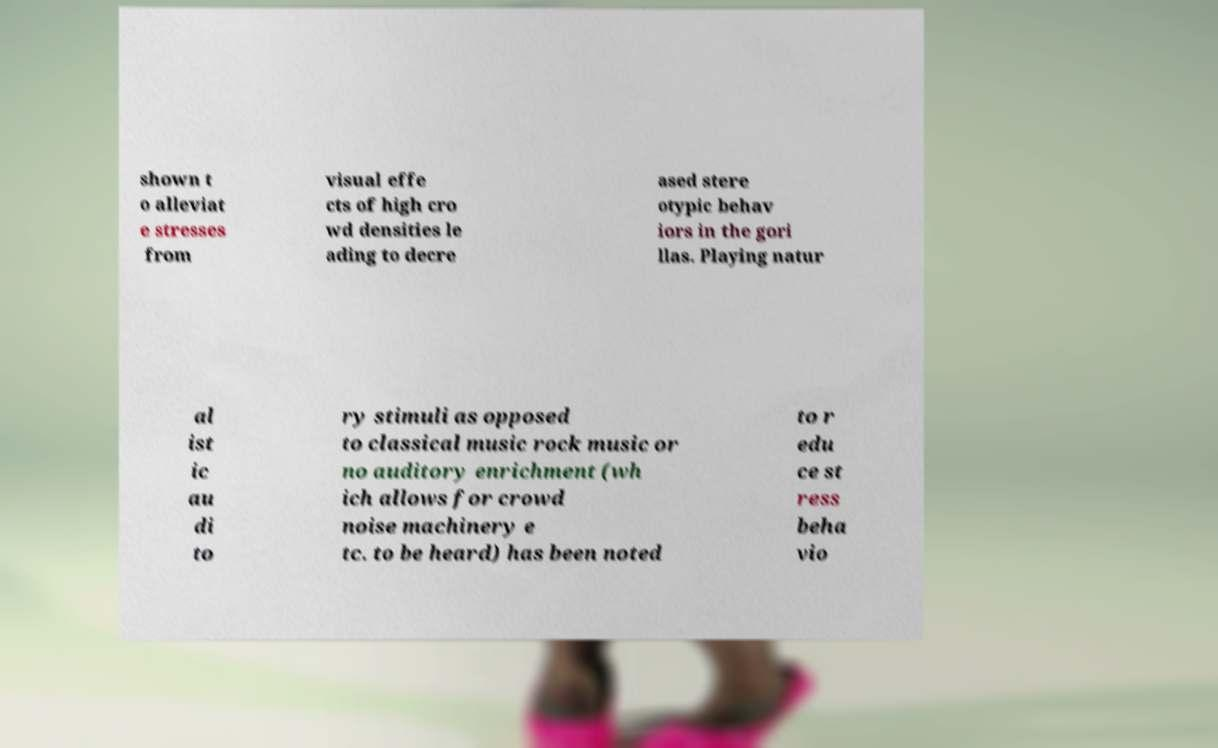For documentation purposes, I need the text within this image transcribed. Could you provide that? shown t o alleviat e stresses from visual effe cts of high cro wd densities le ading to decre ased stere otypic behav iors in the gori llas. Playing natur al ist ic au di to ry stimuli as opposed to classical music rock music or no auditory enrichment (wh ich allows for crowd noise machinery e tc. to be heard) has been noted to r edu ce st ress beha vio 